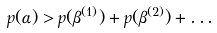Convert formula to latex. <formula><loc_0><loc_0><loc_500><loc_500>p ( \alpha ) > p ( \beta ^ { ( 1 ) } ) + p ( \beta ^ { ( 2 ) } ) + \dots</formula> 